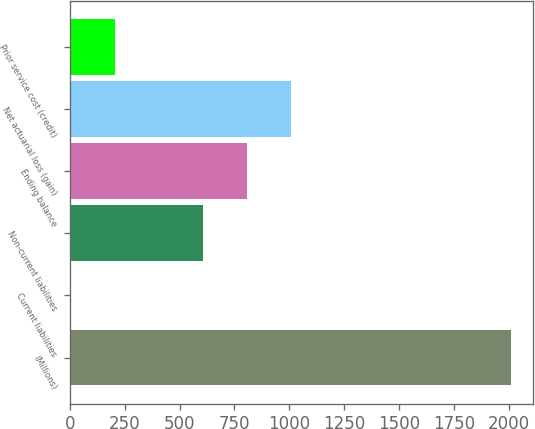Convert chart. <chart><loc_0><loc_0><loc_500><loc_500><bar_chart><fcel>(Millions)<fcel>Current liabilities<fcel>Non-current liabilities<fcel>Ending balance<fcel>Net actuarial loss (gain)<fcel>Prior service cost (credit)<nl><fcel>2013<fcel>4<fcel>608<fcel>808.9<fcel>1009.8<fcel>204.9<nl></chart> 